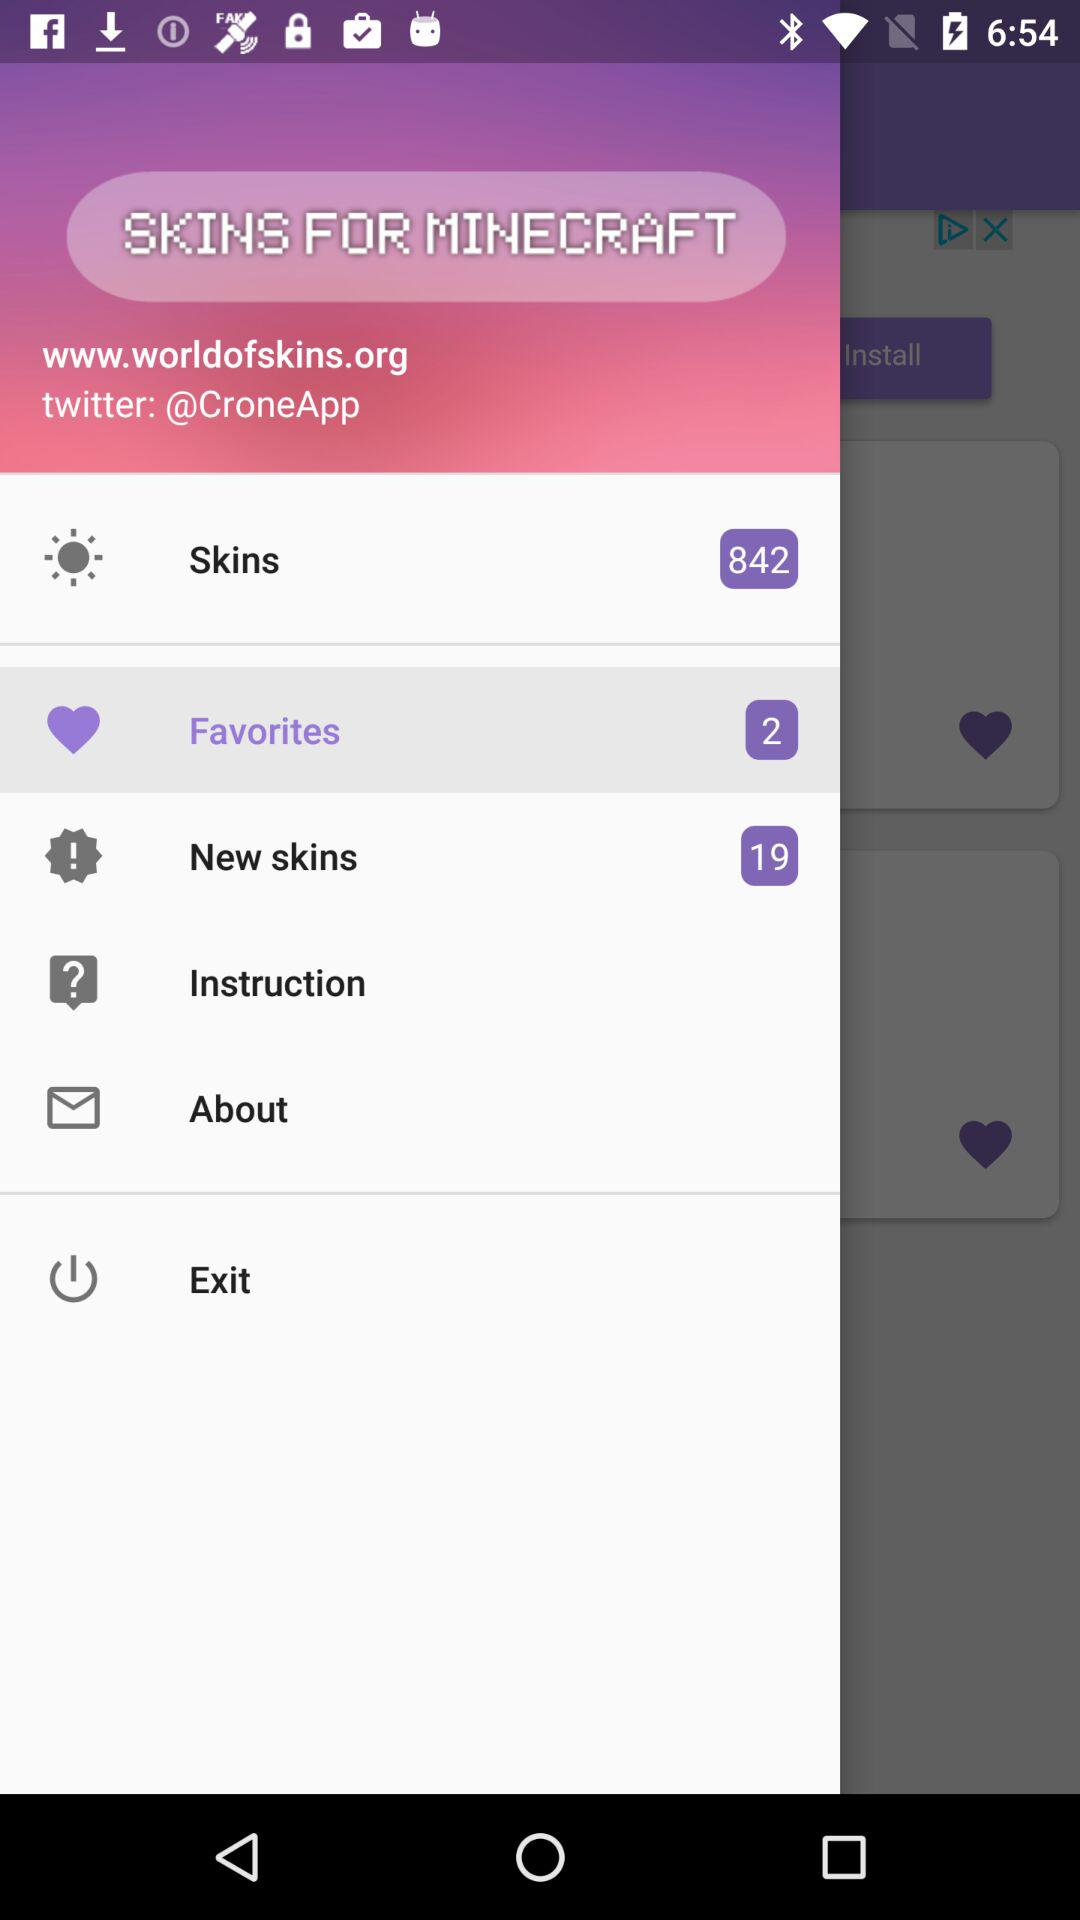What is the domain name? The domain name is worldofskins.org. 